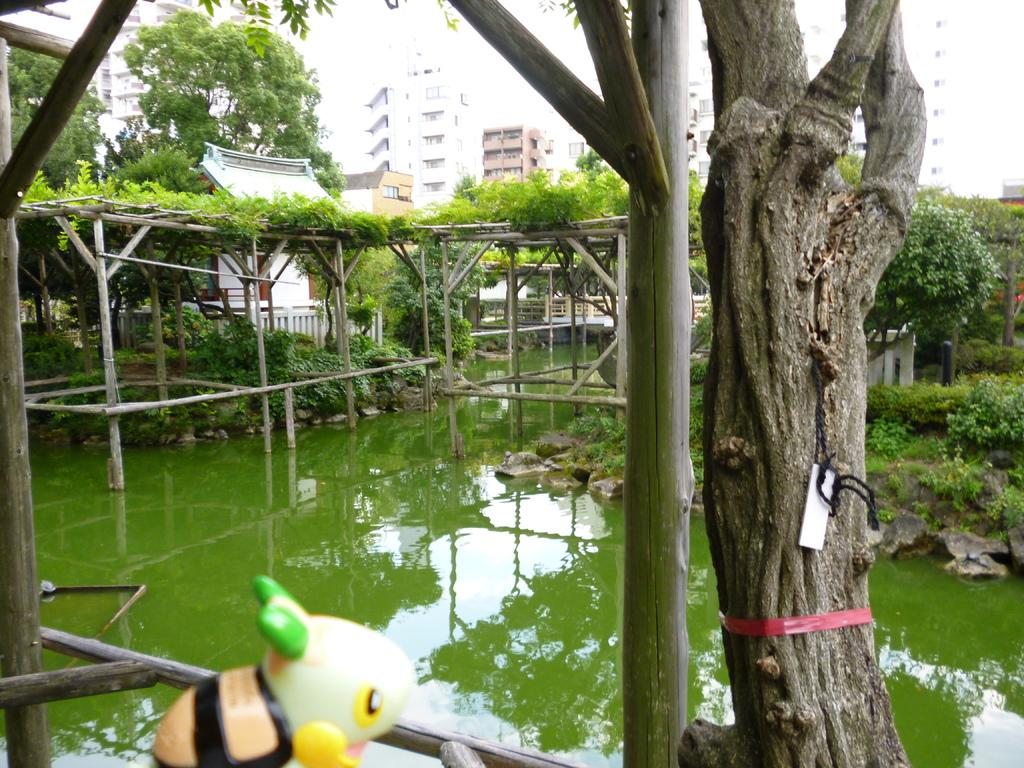Where was the picture taken? The picture was clicked outside. What can be seen in the foreground of the image? There is bamboo in the foreground. What is the main feature in the center of the image? There is a water body in the center of the image. What type of vegetation is present in the image? Grass and plants are visible in the image. What type of structures can be seen in the image? There are buildings in the image. What other objects can be seen in the image? There are other objects in the image. What language is the beginner learning in the image? There is no indication of language learning in the image. Is there a sink visible in the image? There is no sink present in the image. 